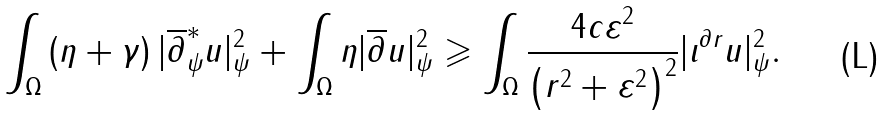<formula> <loc_0><loc_0><loc_500><loc_500>\int _ { \Omega } \left ( \eta + \gamma \right ) | \overline { \partial } ^ { * } _ { \psi } { u } | ^ { 2 } _ { \psi } + \int _ { \Omega } \eta | \overline { \partial } { u } | ^ { 2 } _ { \psi } \geqslant \int _ { \Omega } \frac { 4 c \varepsilon ^ { 2 } } { \left ( r ^ { 2 } + \varepsilon ^ { 2 } \right ) ^ { 2 } } | \iota ^ { \partial { r } } u | _ { \psi } ^ { 2 } .</formula> 